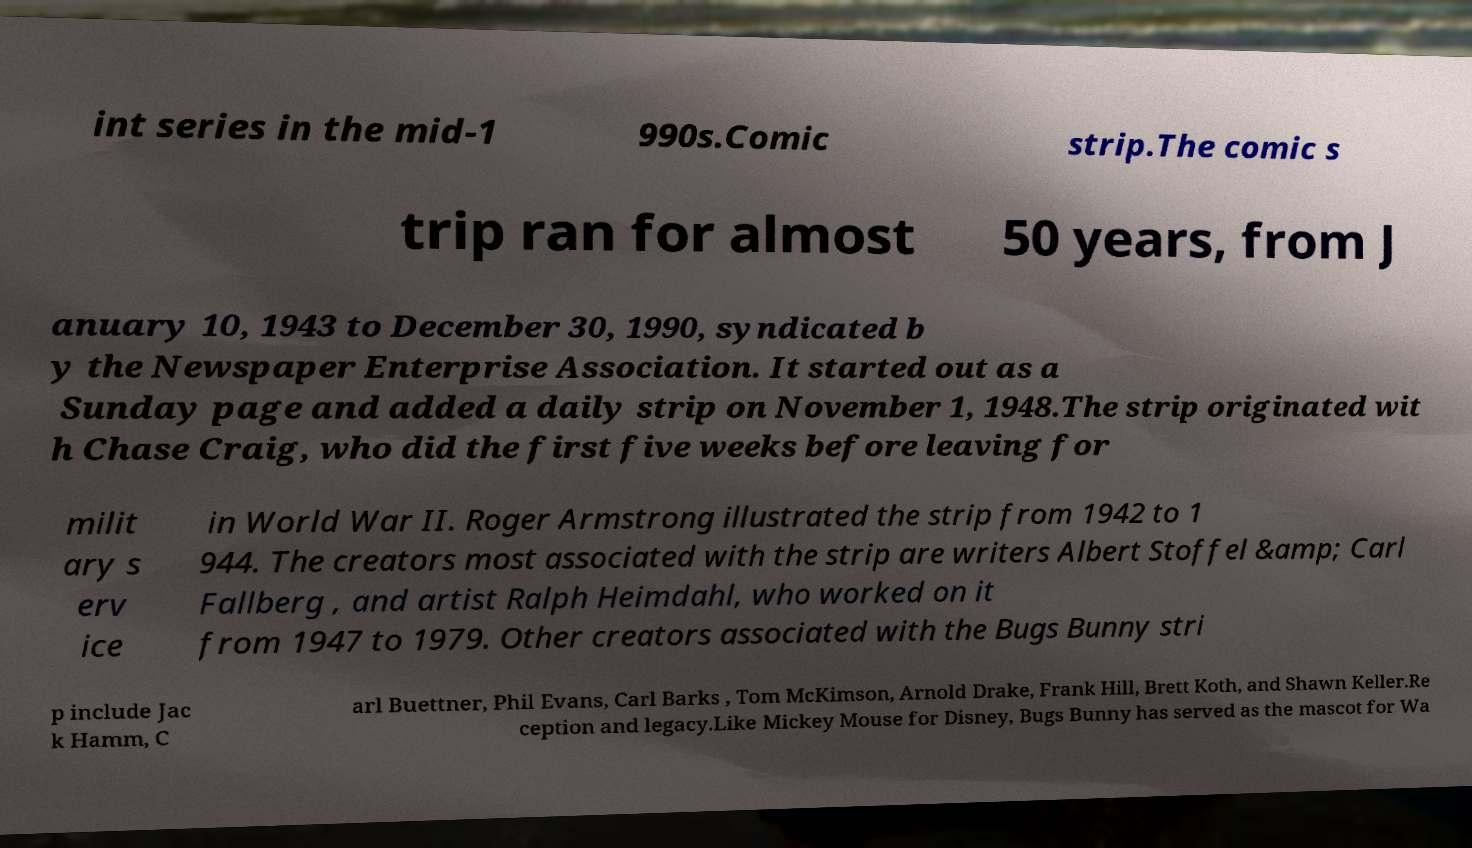Could you extract and type out the text from this image? int series in the mid-1 990s.Comic strip.The comic s trip ran for almost 50 years, from J anuary 10, 1943 to December 30, 1990, syndicated b y the Newspaper Enterprise Association. It started out as a Sunday page and added a daily strip on November 1, 1948.The strip originated wit h Chase Craig, who did the first five weeks before leaving for milit ary s erv ice in World War II. Roger Armstrong illustrated the strip from 1942 to 1 944. The creators most associated with the strip are writers Albert Stoffel &amp; Carl Fallberg , and artist Ralph Heimdahl, who worked on it from 1947 to 1979. Other creators associated with the Bugs Bunny stri p include Jac k Hamm, C arl Buettner, Phil Evans, Carl Barks , Tom McKimson, Arnold Drake, Frank Hill, Brett Koth, and Shawn Keller.Re ception and legacy.Like Mickey Mouse for Disney, Bugs Bunny has served as the mascot for Wa 